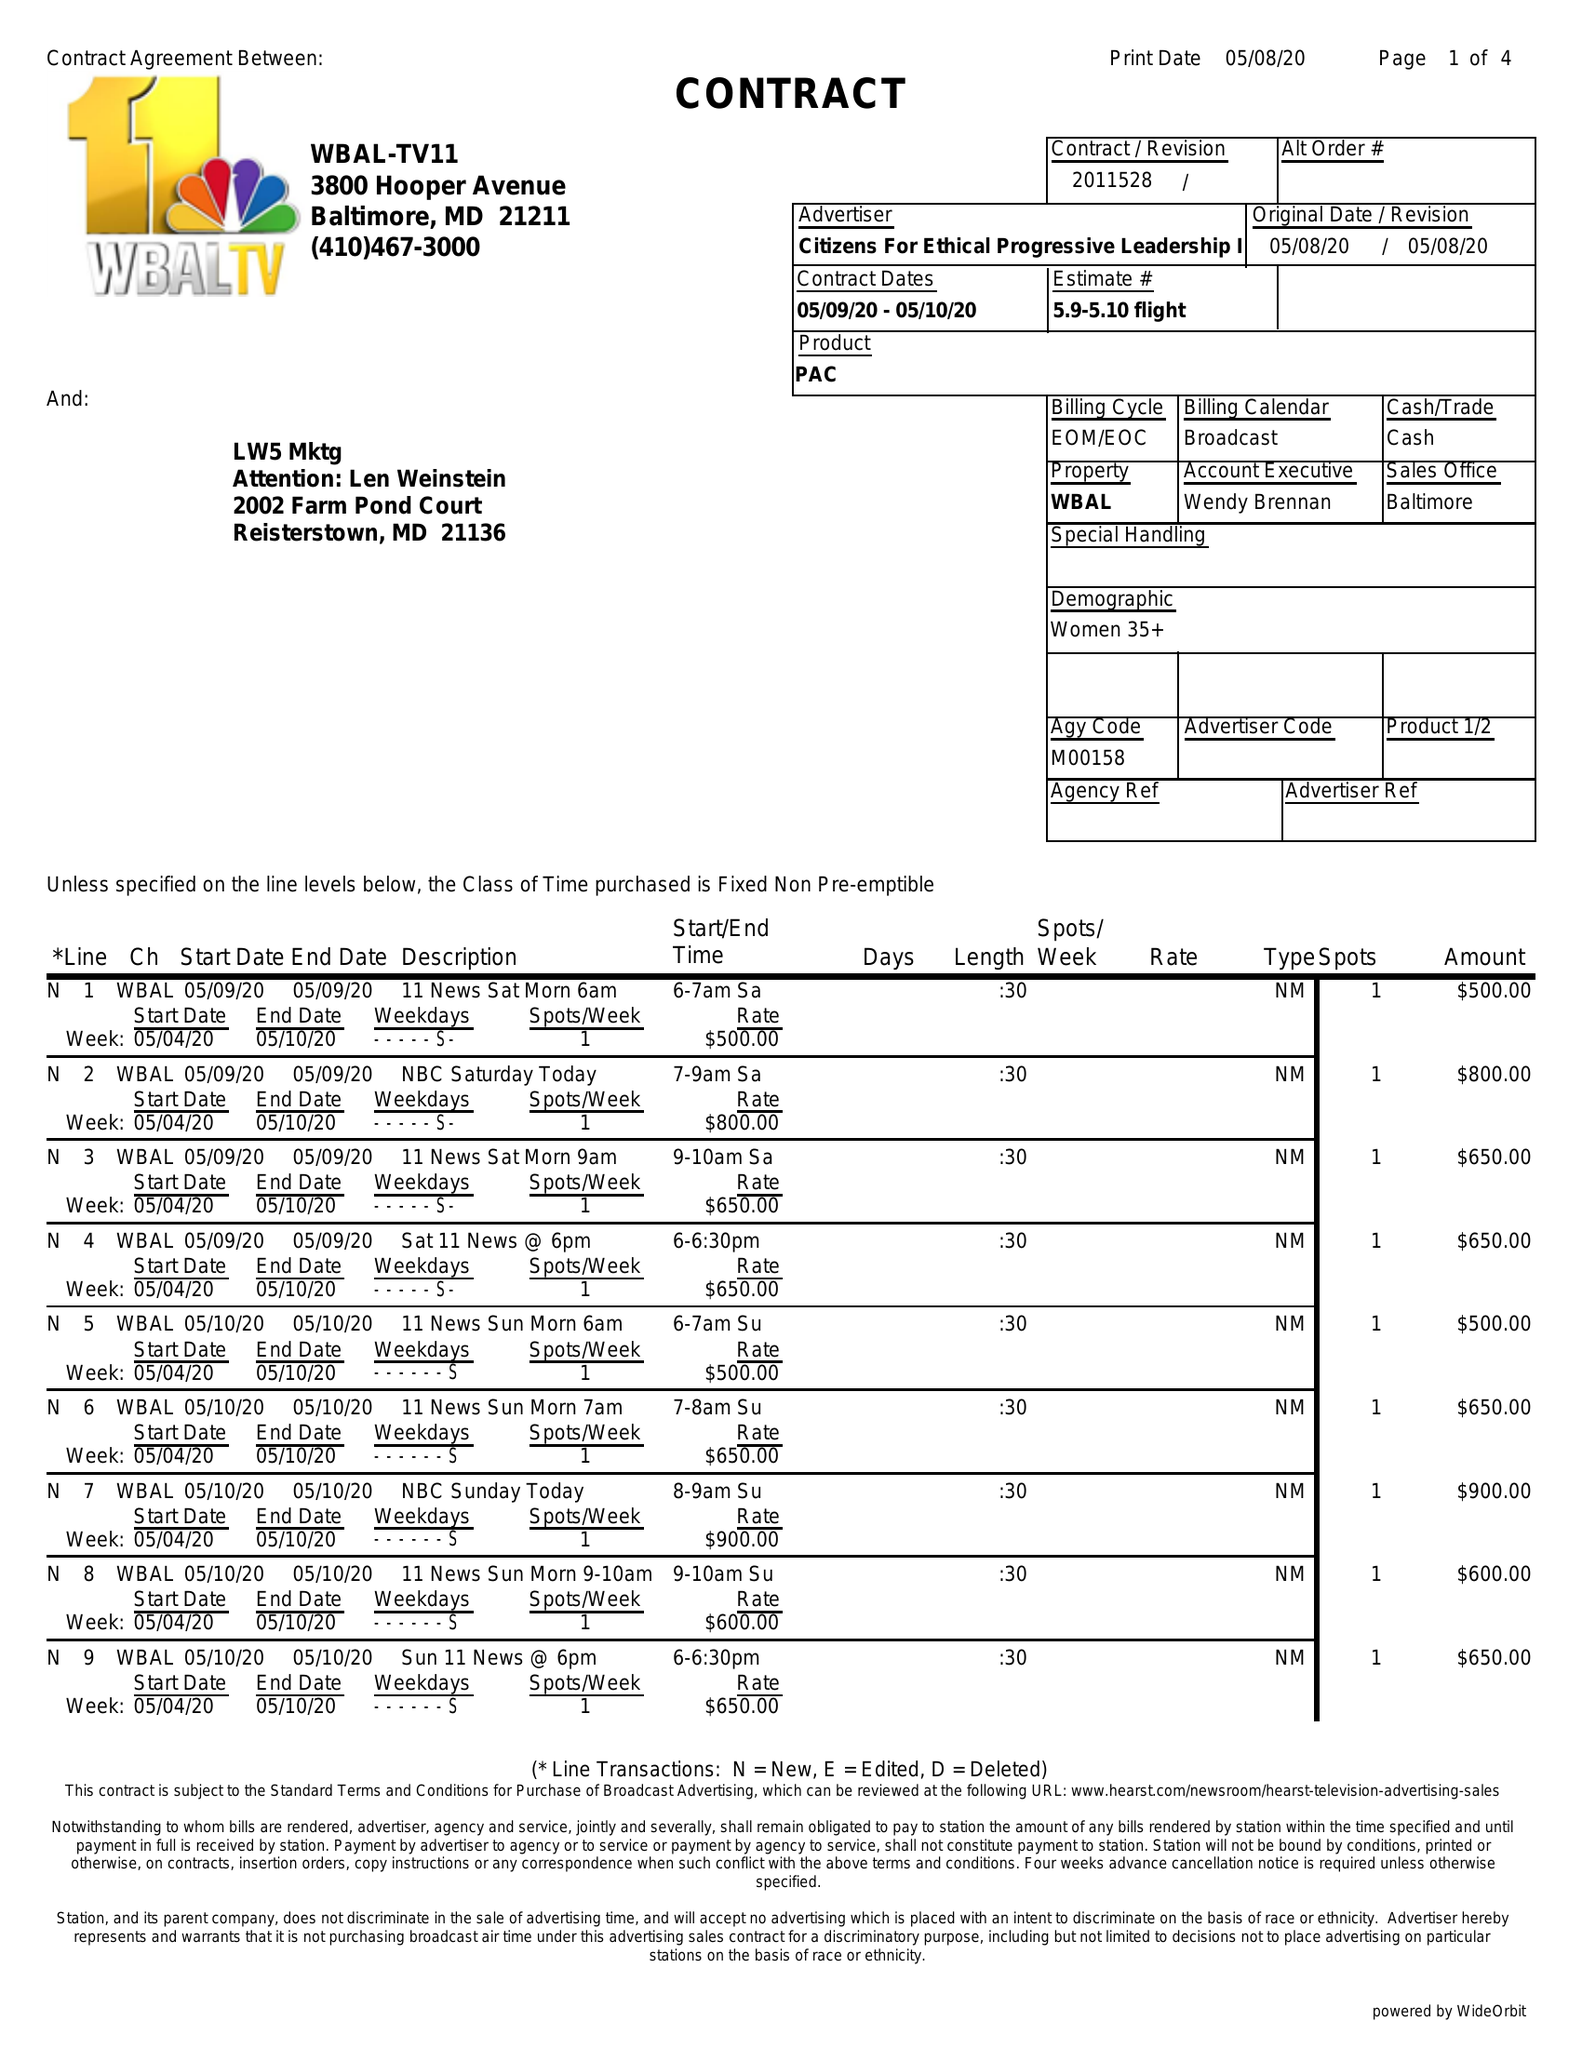What is the value for the advertiser?
Answer the question using a single word or phrase. CITIZENS FOR ETHICAL PROGRESSIVE LEADERSHIP 